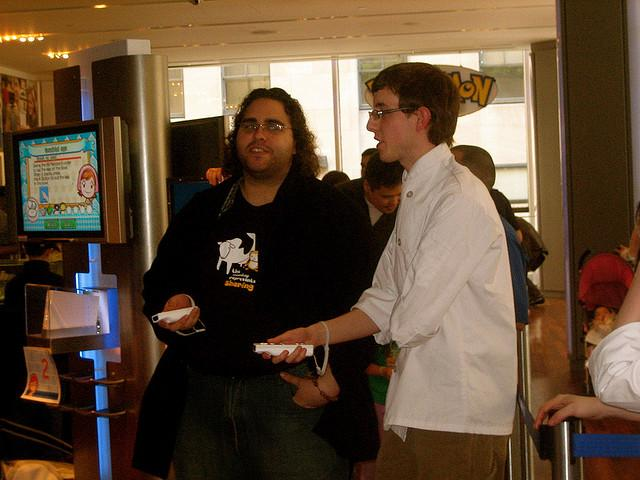What major gaming franchise is being advertised on the window? pokemon 